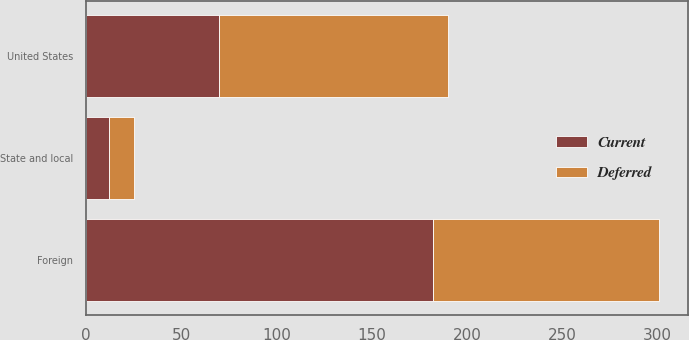Convert chart. <chart><loc_0><loc_0><loc_500><loc_500><stacked_bar_chart><ecel><fcel>United States<fcel>Foreign<fcel>State and local<nl><fcel>Current<fcel>70<fcel>182<fcel>12<nl><fcel>Deferred<fcel>120<fcel>119<fcel>13<nl></chart> 